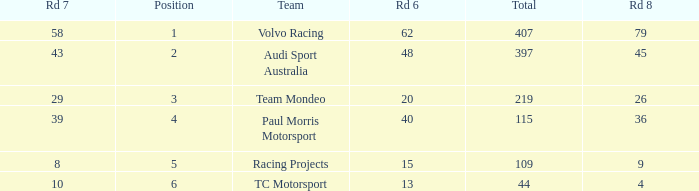What is the average value for Rd 8 in a position less than 2 for Audi Sport Australia? None. 